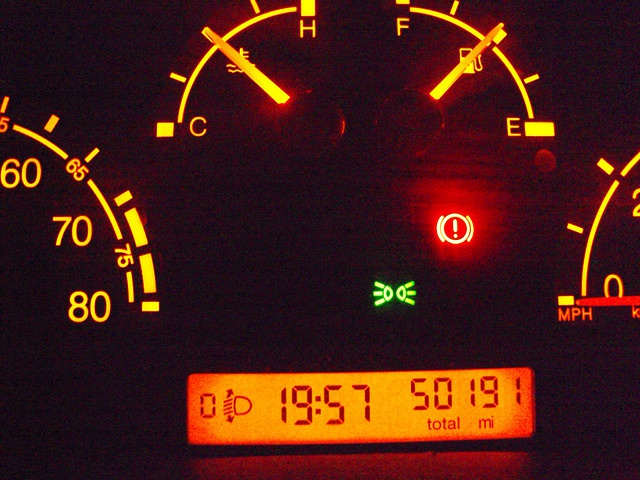Describe the objects in this image and their specific colors. I can see a clock in black, orange, red, and maroon tones in this image. 